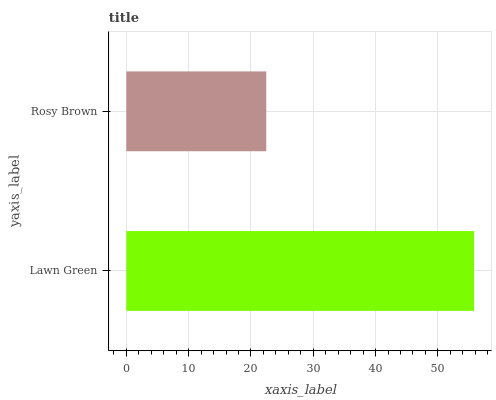Is Rosy Brown the minimum?
Answer yes or no. Yes. Is Lawn Green the maximum?
Answer yes or no. Yes. Is Rosy Brown the maximum?
Answer yes or no. No. Is Lawn Green greater than Rosy Brown?
Answer yes or no. Yes. Is Rosy Brown less than Lawn Green?
Answer yes or no. Yes. Is Rosy Brown greater than Lawn Green?
Answer yes or no. No. Is Lawn Green less than Rosy Brown?
Answer yes or no. No. Is Lawn Green the high median?
Answer yes or no. Yes. Is Rosy Brown the low median?
Answer yes or no. Yes. Is Rosy Brown the high median?
Answer yes or no. No. Is Lawn Green the low median?
Answer yes or no. No. 